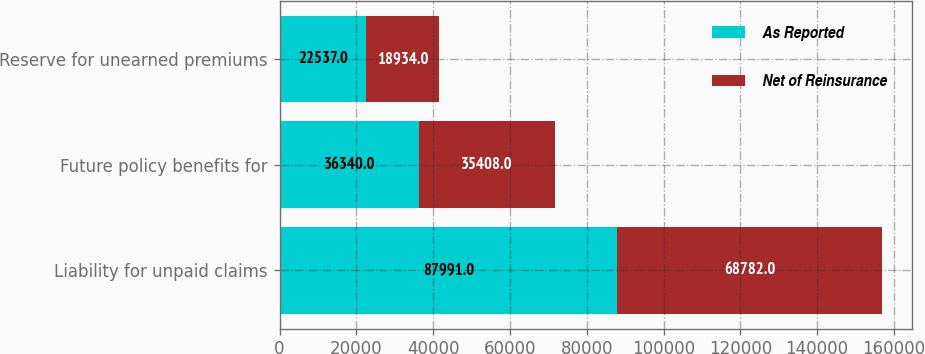Convert chart. <chart><loc_0><loc_0><loc_500><loc_500><stacked_bar_chart><ecel><fcel>Liability for unpaid claims<fcel>Future policy benefits for<fcel>Reserve for unearned premiums<nl><fcel>As Reported<fcel>87991<fcel>36340<fcel>22537<nl><fcel>Net of Reinsurance<fcel>68782<fcel>35408<fcel>18934<nl></chart> 